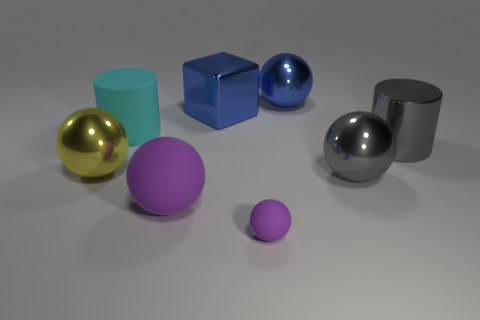Add 1 large metal objects. How many objects exist? 9 Subtract all blocks. How many objects are left? 7 Subtract 1 blue blocks. How many objects are left? 7 Subtract all big blue shiny things. Subtract all small purple balls. How many objects are left? 5 Add 2 big cyan cylinders. How many big cyan cylinders are left? 3 Add 6 big purple spheres. How many big purple spheres exist? 7 